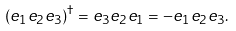Convert formula to latex. <formula><loc_0><loc_0><loc_500><loc_500>( e _ { 1 } e _ { 2 } e _ { 3 } ) ^ { \dagger } = e _ { 3 } e _ { 2 } e _ { 1 } = - e _ { 1 } e _ { 2 } e _ { 3 } .</formula> 